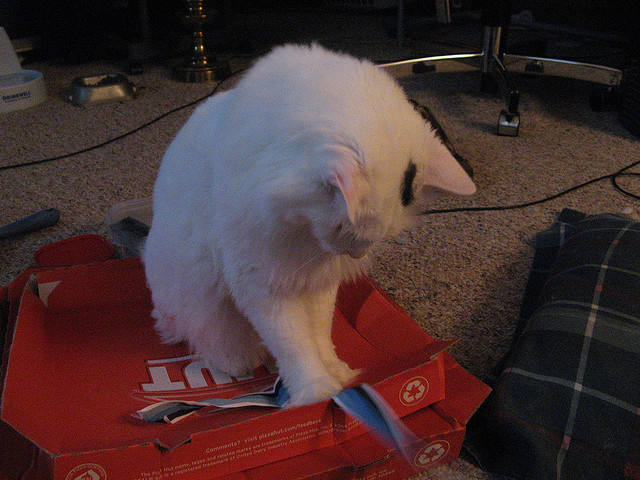Identify the text displayed in this image. HUT 